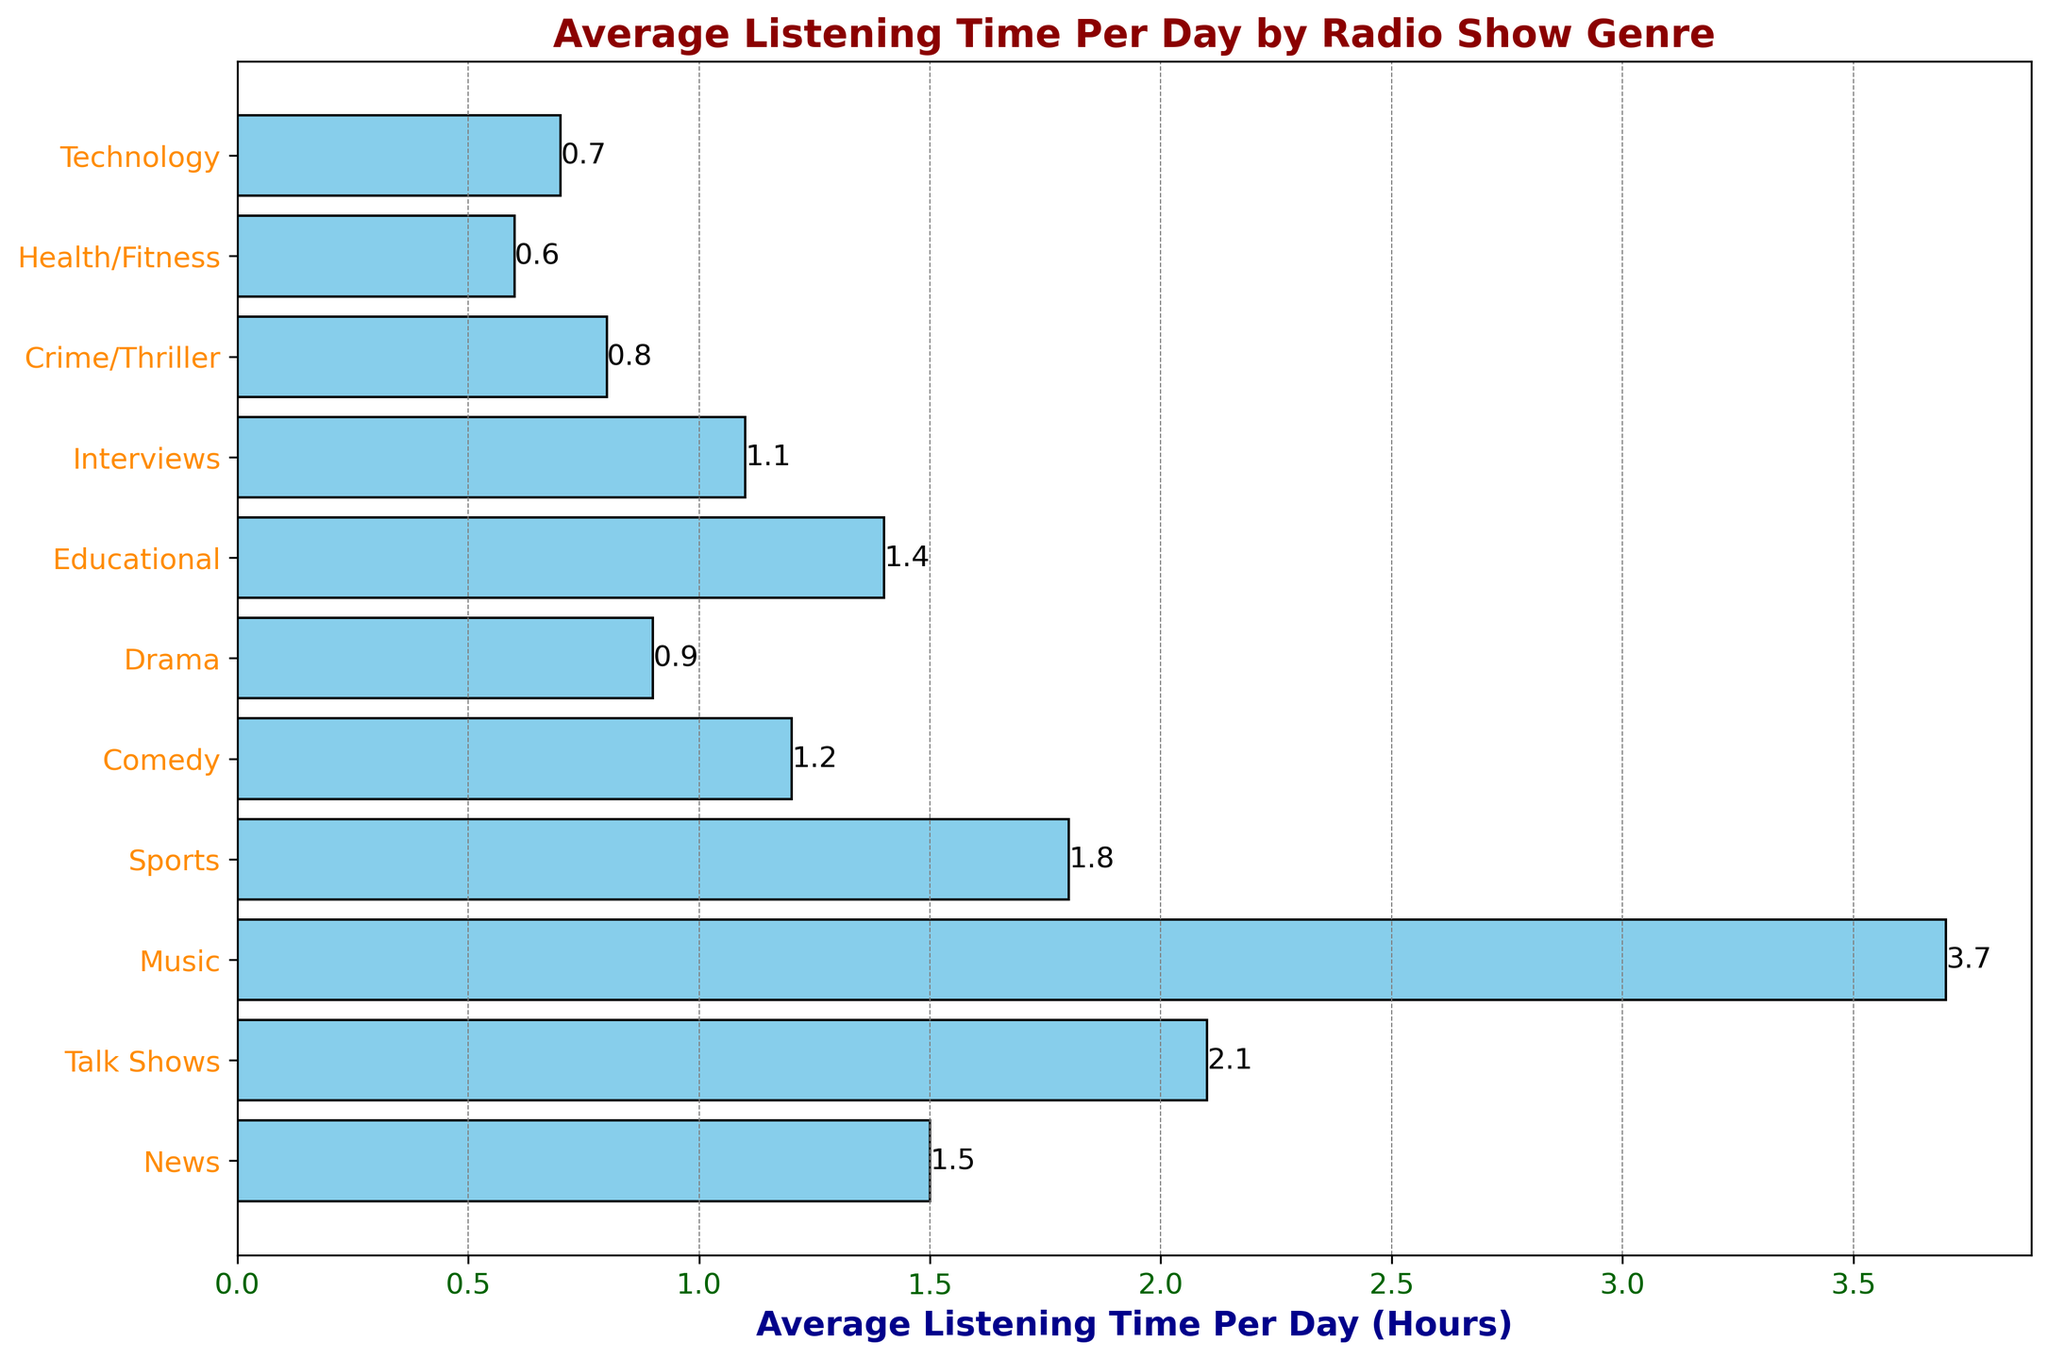What's the genre with the highest average listening time per day? The bar chart shows multiple genres, and we look for the bar with the greatest length. That bar corresponds to 'Music', which has an average listening time of 3.7 hours per day.
Answer: Music Which genre has the lowest average listening time per day? We look at the bar with the smallest length. The shortest bar corresponds to 'Health/Fitness' with an average listening time of 0.6 hours per day.
Answer: Health/Fitness What is the total average listening time per day for both 'News' and 'Talk Shows'? To find the total average listening time for 'News' and 'Talk Shows', we simply add their average times: 1.5 hours (News) + 2.1 hours (Talk Shows) = 3.6 hours.
Answer: 3.6 hours Is the average listening time for 'Comedy' greater than that for 'Drama'? We compare the lengths of the bars for 'Comedy' and 'Drama'. 'Comedy' has a listening time of 1.2 hours, whereas 'Drama' has 0.9 hours. Since 1.2 is greater than 0.9, 'Comedy' has the higher listening time.
Answer: Yes What is the combined average listening time for 'Sports,' 'Educational,' and 'Interviews'? To find the combined average listening time, we sum the average times for 'Sports' (1.8 hours), 'Educational' (1.4 hours), and 'Interviews' (1.1 hours): 1.8 + 1.4 + 1.1 = 4.3 hours.
Answer: 4.3 hours By how much is the average listening time for 'Music' greater than 'Comedy'? We subtract the average listening time of 'Comedy' from 'Music': 3.7 hours (Music) - 1.2 hours (Comedy) = 2.5 hours.
Answer: 2.5 hours Which genres have an average listening time of less than 1 hour per day? We identify the bars with a length less than 1. The genres 'Drama' (0.9 hours), 'Crime/Thriller' (0.8 hours), 'Health/Fitness' (0.6 hours), and 'Technology' (0.7 hours) all have less than 1 hour of average listening time.
Answer: Drama, Crime/Thriller, Health/Fitness, Technology What is the median average listening time per day across all genres? To find the median, we list the average listening times in ascending order: 0.6, 0.7, 0.8, 0.9, 1.1, 1.2, 1.4, 1.5, 1.8, 2.1, 3.7. With 11 data points, the median is the 6th value in this ordered list, which is 1.2 hours.
Answer: 1.2 hours What’s the difference in average listening time between 'News' and 'Technology'? Subtract the average listening time of 'Technology' from 'News': 1.5 hours (News) - 0.7 hours (Technology) = 0.8 hours.
Answer: 0.8 hours How many genres have an average listening time of at least 1.5 hours per day? By counting the bars whose lengths are 1.5 or more, we identify four genres: 'News' (1.5), 'Talk Shows' (2.1), 'Music' (3.7), and 'Sports' (1.8).
Answer: 4 Genres 